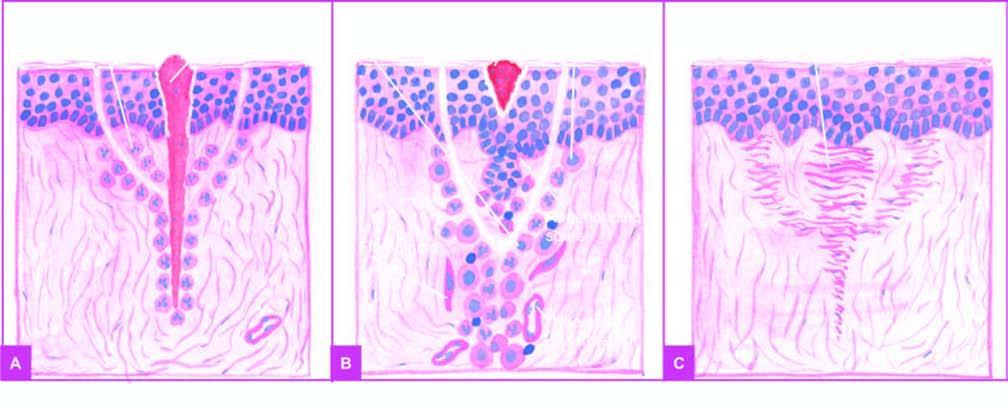re the vesselwall filled with blood clot?
Answer the question using a single word or phrase. No 